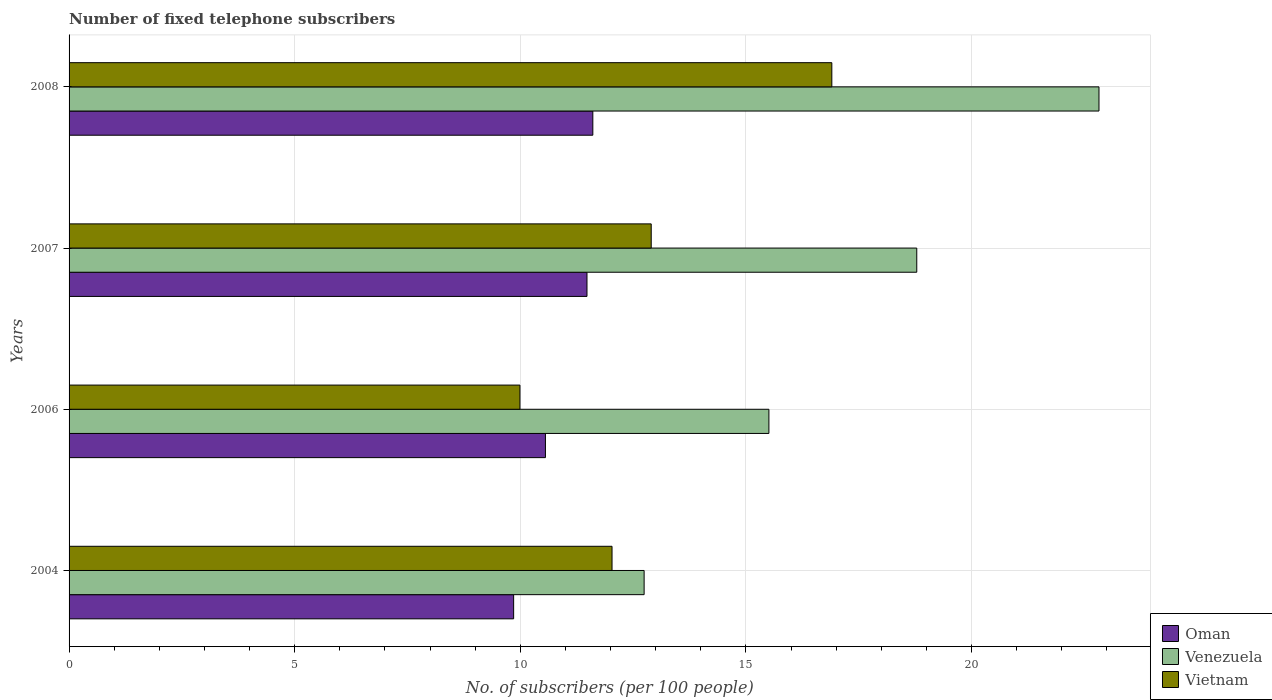How many different coloured bars are there?
Give a very brief answer. 3. Are the number of bars on each tick of the Y-axis equal?
Ensure brevity in your answer.  Yes. How many bars are there on the 3rd tick from the top?
Your answer should be very brief. 3. How many bars are there on the 1st tick from the bottom?
Provide a succinct answer. 3. What is the label of the 1st group of bars from the top?
Your answer should be compact. 2008. What is the number of fixed telephone subscribers in Venezuela in 2008?
Provide a succinct answer. 22.82. Across all years, what is the maximum number of fixed telephone subscribers in Venezuela?
Give a very brief answer. 22.82. Across all years, what is the minimum number of fixed telephone subscribers in Oman?
Keep it short and to the point. 9.85. In which year was the number of fixed telephone subscribers in Vietnam maximum?
Your answer should be very brief. 2008. In which year was the number of fixed telephone subscribers in Venezuela minimum?
Your answer should be very brief. 2004. What is the total number of fixed telephone subscribers in Venezuela in the graph?
Provide a succinct answer. 69.86. What is the difference between the number of fixed telephone subscribers in Venezuela in 2007 and that in 2008?
Keep it short and to the point. -4.04. What is the difference between the number of fixed telephone subscribers in Oman in 2006 and the number of fixed telephone subscribers in Vietnam in 2008?
Offer a terse response. -6.35. What is the average number of fixed telephone subscribers in Vietnam per year?
Your answer should be very brief. 12.96. In the year 2008, what is the difference between the number of fixed telephone subscribers in Vietnam and number of fixed telephone subscribers in Venezuela?
Provide a succinct answer. -5.92. What is the ratio of the number of fixed telephone subscribers in Oman in 2004 to that in 2008?
Provide a short and direct response. 0.85. Is the number of fixed telephone subscribers in Venezuela in 2004 less than that in 2007?
Your answer should be compact. Yes. Is the difference between the number of fixed telephone subscribers in Vietnam in 2004 and 2008 greater than the difference between the number of fixed telephone subscribers in Venezuela in 2004 and 2008?
Ensure brevity in your answer.  Yes. What is the difference between the highest and the second highest number of fixed telephone subscribers in Oman?
Your answer should be very brief. 0.13. What is the difference between the highest and the lowest number of fixed telephone subscribers in Vietnam?
Your answer should be compact. 6.91. What does the 2nd bar from the top in 2004 represents?
Ensure brevity in your answer.  Venezuela. What does the 3rd bar from the bottom in 2007 represents?
Your answer should be compact. Vietnam. Is it the case that in every year, the sum of the number of fixed telephone subscribers in Venezuela and number of fixed telephone subscribers in Vietnam is greater than the number of fixed telephone subscribers in Oman?
Make the answer very short. Yes. Are all the bars in the graph horizontal?
Offer a terse response. Yes. How many years are there in the graph?
Your answer should be very brief. 4. Are the values on the major ticks of X-axis written in scientific E-notation?
Keep it short and to the point. No. Does the graph contain any zero values?
Your response must be concise. No. Does the graph contain grids?
Give a very brief answer. Yes. Where does the legend appear in the graph?
Give a very brief answer. Bottom right. How many legend labels are there?
Your answer should be compact. 3. How are the legend labels stacked?
Provide a short and direct response. Vertical. What is the title of the graph?
Provide a succinct answer. Number of fixed telephone subscribers. Does "Grenada" appear as one of the legend labels in the graph?
Provide a short and direct response. No. What is the label or title of the X-axis?
Provide a succinct answer. No. of subscribers (per 100 people). What is the No. of subscribers (per 100 people) in Oman in 2004?
Offer a terse response. 9.85. What is the No. of subscribers (per 100 people) in Venezuela in 2004?
Offer a very short reply. 12.74. What is the No. of subscribers (per 100 people) of Vietnam in 2004?
Offer a terse response. 12.03. What is the No. of subscribers (per 100 people) in Oman in 2006?
Offer a very short reply. 10.56. What is the No. of subscribers (per 100 people) of Venezuela in 2006?
Keep it short and to the point. 15.51. What is the No. of subscribers (per 100 people) of Vietnam in 2006?
Offer a terse response. 9.99. What is the No. of subscribers (per 100 people) of Oman in 2007?
Ensure brevity in your answer.  11.48. What is the No. of subscribers (per 100 people) in Venezuela in 2007?
Your answer should be compact. 18.78. What is the No. of subscribers (per 100 people) of Vietnam in 2007?
Give a very brief answer. 12.9. What is the No. of subscribers (per 100 people) in Oman in 2008?
Offer a terse response. 11.61. What is the No. of subscribers (per 100 people) in Venezuela in 2008?
Offer a terse response. 22.82. What is the No. of subscribers (per 100 people) of Vietnam in 2008?
Offer a very short reply. 16.9. Across all years, what is the maximum No. of subscribers (per 100 people) of Oman?
Give a very brief answer. 11.61. Across all years, what is the maximum No. of subscribers (per 100 people) in Venezuela?
Make the answer very short. 22.82. Across all years, what is the maximum No. of subscribers (per 100 people) in Vietnam?
Your answer should be very brief. 16.9. Across all years, what is the minimum No. of subscribers (per 100 people) in Oman?
Provide a succinct answer. 9.85. Across all years, what is the minimum No. of subscribers (per 100 people) of Venezuela?
Make the answer very short. 12.74. Across all years, what is the minimum No. of subscribers (per 100 people) in Vietnam?
Provide a short and direct response. 9.99. What is the total No. of subscribers (per 100 people) in Oman in the graph?
Give a very brief answer. 43.49. What is the total No. of subscribers (per 100 people) in Venezuela in the graph?
Offer a terse response. 69.86. What is the total No. of subscribers (per 100 people) in Vietnam in the graph?
Provide a short and direct response. 51.83. What is the difference between the No. of subscribers (per 100 people) in Oman in 2004 and that in 2006?
Keep it short and to the point. -0.7. What is the difference between the No. of subscribers (per 100 people) in Venezuela in 2004 and that in 2006?
Your answer should be compact. -2.77. What is the difference between the No. of subscribers (per 100 people) in Vietnam in 2004 and that in 2006?
Offer a very short reply. 2.04. What is the difference between the No. of subscribers (per 100 people) of Oman in 2004 and that in 2007?
Provide a short and direct response. -1.62. What is the difference between the No. of subscribers (per 100 people) of Venezuela in 2004 and that in 2007?
Give a very brief answer. -6.04. What is the difference between the No. of subscribers (per 100 people) in Vietnam in 2004 and that in 2007?
Provide a short and direct response. -0.87. What is the difference between the No. of subscribers (per 100 people) of Oman in 2004 and that in 2008?
Provide a succinct answer. -1.75. What is the difference between the No. of subscribers (per 100 people) in Venezuela in 2004 and that in 2008?
Your response must be concise. -10.08. What is the difference between the No. of subscribers (per 100 people) of Vietnam in 2004 and that in 2008?
Your answer should be compact. -4.87. What is the difference between the No. of subscribers (per 100 people) in Oman in 2006 and that in 2007?
Your response must be concise. -0.92. What is the difference between the No. of subscribers (per 100 people) in Venezuela in 2006 and that in 2007?
Provide a succinct answer. -3.28. What is the difference between the No. of subscribers (per 100 people) of Vietnam in 2006 and that in 2007?
Keep it short and to the point. -2.91. What is the difference between the No. of subscribers (per 100 people) in Oman in 2006 and that in 2008?
Your answer should be compact. -1.05. What is the difference between the No. of subscribers (per 100 people) in Venezuela in 2006 and that in 2008?
Give a very brief answer. -7.31. What is the difference between the No. of subscribers (per 100 people) of Vietnam in 2006 and that in 2008?
Offer a terse response. -6.91. What is the difference between the No. of subscribers (per 100 people) in Oman in 2007 and that in 2008?
Ensure brevity in your answer.  -0.13. What is the difference between the No. of subscribers (per 100 people) of Venezuela in 2007 and that in 2008?
Your answer should be compact. -4.04. What is the difference between the No. of subscribers (per 100 people) of Vietnam in 2007 and that in 2008?
Give a very brief answer. -4. What is the difference between the No. of subscribers (per 100 people) in Oman in 2004 and the No. of subscribers (per 100 people) in Venezuela in 2006?
Your answer should be compact. -5.66. What is the difference between the No. of subscribers (per 100 people) of Oman in 2004 and the No. of subscribers (per 100 people) of Vietnam in 2006?
Provide a short and direct response. -0.14. What is the difference between the No. of subscribers (per 100 people) in Venezuela in 2004 and the No. of subscribers (per 100 people) in Vietnam in 2006?
Provide a short and direct response. 2.75. What is the difference between the No. of subscribers (per 100 people) in Oman in 2004 and the No. of subscribers (per 100 people) in Venezuela in 2007?
Offer a very short reply. -8.93. What is the difference between the No. of subscribers (per 100 people) in Oman in 2004 and the No. of subscribers (per 100 people) in Vietnam in 2007?
Keep it short and to the point. -3.05. What is the difference between the No. of subscribers (per 100 people) of Venezuela in 2004 and the No. of subscribers (per 100 people) of Vietnam in 2007?
Provide a succinct answer. -0.16. What is the difference between the No. of subscribers (per 100 people) in Oman in 2004 and the No. of subscribers (per 100 people) in Venezuela in 2008?
Provide a short and direct response. -12.97. What is the difference between the No. of subscribers (per 100 people) of Oman in 2004 and the No. of subscribers (per 100 people) of Vietnam in 2008?
Your response must be concise. -7.05. What is the difference between the No. of subscribers (per 100 people) in Venezuela in 2004 and the No. of subscribers (per 100 people) in Vietnam in 2008?
Offer a very short reply. -4.16. What is the difference between the No. of subscribers (per 100 people) of Oman in 2006 and the No. of subscribers (per 100 people) of Venezuela in 2007?
Provide a short and direct response. -8.23. What is the difference between the No. of subscribers (per 100 people) of Oman in 2006 and the No. of subscribers (per 100 people) of Vietnam in 2007?
Your answer should be very brief. -2.34. What is the difference between the No. of subscribers (per 100 people) in Venezuela in 2006 and the No. of subscribers (per 100 people) in Vietnam in 2007?
Your answer should be very brief. 2.61. What is the difference between the No. of subscribers (per 100 people) of Oman in 2006 and the No. of subscribers (per 100 people) of Venezuela in 2008?
Offer a very short reply. -12.27. What is the difference between the No. of subscribers (per 100 people) of Oman in 2006 and the No. of subscribers (per 100 people) of Vietnam in 2008?
Your response must be concise. -6.35. What is the difference between the No. of subscribers (per 100 people) in Venezuela in 2006 and the No. of subscribers (per 100 people) in Vietnam in 2008?
Give a very brief answer. -1.39. What is the difference between the No. of subscribers (per 100 people) in Oman in 2007 and the No. of subscribers (per 100 people) in Venezuela in 2008?
Your answer should be compact. -11.35. What is the difference between the No. of subscribers (per 100 people) in Oman in 2007 and the No. of subscribers (per 100 people) in Vietnam in 2008?
Offer a terse response. -5.43. What is the difference between the No. of subscribers (per 100 people) in Venezuela in 2007 and the No. of subscribers (per 100 people) in Vietnam in 2008?
Your answer should be compact. 1.88. What is the average No. of subscribers (per 100 people) in Oman per year?
Offer a very short reply. 10.87. What is the average No. of subscribers (per 100 people) of Venezuela per year?
Your response must be concise. 17.46. What is the average No. of subscribers (per 100 people) of Vietnam per year?
Your answer should be very brief. 12.96. In the year 2004, what is the difference between the No. of subscribers (per 100 people) in Oman and No. of subscribers (per 100 people) in Venezuela?
Make the answer very short. -2.89. In the year 2004, what is the difference between the No. of subscribers (per 100 people) in Oman and No. of subscribers (per 100 people) in Vietnam?
Provide a short and direct response. -2.18. In the year 2004, what is the difference between the No. of subscribers (per 100 people) of Venezuela and No. of subscribers (per 100 people) of Vietnam?
Your answer should be compact. 0.71. In the year 2006, what is the difference between the No. of subscribers (per 100 people) in Oman and No. of subscribers (per 100 people) in Venezuela?
Your answer should be compact. -4.95. In the year 2006, what is the difference between the No. of subscribers (per 100 people) in Oman and No. of subscribers (per 100 people) in Vietnam?
Keep it short and to the point. 0.56. In the year 2006, what is the difference between the No. of subscribers (per 100 people) of Venezuela and No. of subscribers (per 100 people) of Vietnam?
Give a very brief answer. 5.52. In the year 2007, what is the difference between the No. of subscribers (per 100 people) in Oman and No. of subscribers (per 100 people) in Venezuela?
Give a very brief answer. -7.31. In the year 2007, what is the difference between the No. of subscribers (per 100 people) of Oman and No. of subscribers (per 100 people) of Vietnam?
Your response must be concise. -1.42. In the year 2007, what is the difference between the No. of subscribers (per 100 people) in Venezuela and No. of subscribers (per 100 people) in Vietnam?
Keep it short and to the point. 5.88. In the year 2008, what is the difference between the No. of subscribers (per 100 people) in Oman and No. of subscribers (per 100 people) in Venezuela?
Your answer should be very brief. -11.22. In the year 2008, what is the difference between the No. of subscribers (per 100 people) in Oman and No. of subscribers (per 100 people) in Vietnam?
Your answer should be very brief. -5.3. In the year 2008, what is the difference between the No. of subscribers (per 100 people) of Venezuela and No. of subscribers (per 100 people) of Vietnam?
Make the answer very short. 5.92. What is the ratio of the No. of subscribers (per 100 people) in Venezuela in 2004 to that in 2006?
Make the answer very short. 0.82. What is the ratio of the No. of subscribers (per 100 people) in Vietnam in 2004 to that in 2006?
Make the answer very short. 1.2. What is the ratio of the No. of subscribers (per 100 people) in Oman in 2004 to that in 2007?
Your response must be concise. 0.86. What is the ratio of the No. of subscribers (per 100 people) in Venezuela in 2004 to that in 2007?
Your answer should be compact. 0.68. What is the ratio of the No. of subscribers (per 100 people) in Vietnam in 2004 to that in 2007?
Ensure brevity in your answer.  0.93. What is the ratio of the No. of subscribers (per 100 people) of Oman in 2004 to that in 2008?
Your answer should be very brief. 0.85. What is the ratio of the No. of subscribers (per 100 people) in Venezuela in 2004 to that in 2008?
Keep it short and to the point. 0.56. What is the ratio of the No. of subscribers (per 100 people) of Vietnam in 2004 to that in 2008?
Ensure brevity in your answer.  0.71. What is the ratio of the No. of subscribers (per 100 people) in Oman in 2006 to that in 2007?
Your answer should be very brief. 0.92. What is the ratio of the No. of subscribers (per 100 people) of Venezuela in 2006 to that in 2007?
Give a very brief answer. 0.83. What is the ratio of the No. of subscribers (per 100 people) of Vietnam in 2006 to that in 2007?
Give a very brief answer. 0.77. What is the ratio of the No. of subscribers (per 100 people) of Oman in 2006 to that in 2008?
Offer a terse response. 0.91. What is the ratio of the No. of subscribers (per 100 people) of Venezuela in 2006 to that in 2008?
Your response must be concise. 0.68. What is the ratio of the No. of subscribers (per 100 people) in Vietnam in 2006 to that in 2008?
Make the answer very short. 0.59. What is the ratio of the No. of subscribers (per 100 people) in Venezuela in 2007 to that in 2008?
Provide a succinct answer. 0.82. What is the ratio of the No. of subscribers (per 100 people) of Vietnam in 2007 to that in 2008?
Your answer should be very brief. 0.76. What is the difference between the highest and the second highest No. of subscribers (per 100 people) in Oman?
Keep it short and to the point. 0.13. What is the difference between the highest and the second highest No. of subscribers (per 100 people) in Venezuela?
Provide a short and direct response. 4.04. What is the difference between the highest and the second highest No. of subscribers (per 100 people) of Vietnam?
Your answer should be compact. 4. What is the difference between the highest and the lowest No. of subscribers (per 100 people) in Oman?
Provide a succinct answer. 1.75. What is the difference between the highest and the lowest No. of subscribers (per 100 people) in Venezuela?
Offer a terse response. 10.08. What is the difference between the highest and the lowest No. of subscribers (per 100 people) in Vietnam?
Give a very brief answer. 6.91. 